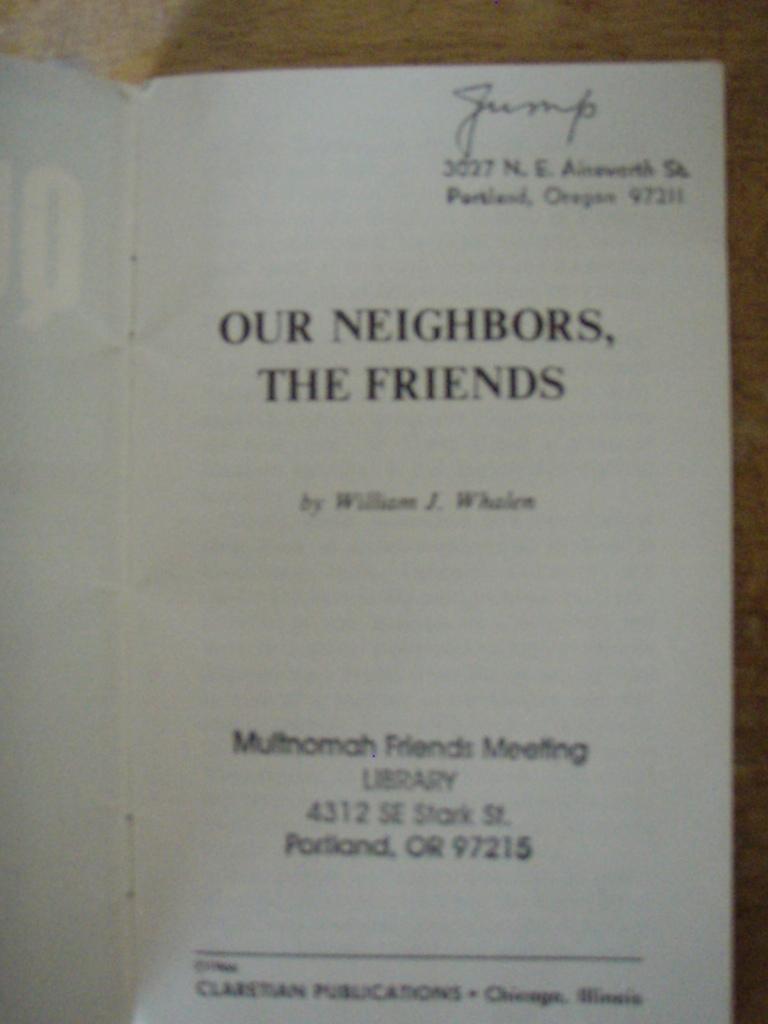What is the title of this book?
Offer a terse response. Our neighbors the friends. Who is the author of the book?
Offer a terse response. William j. whalen. 